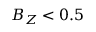Convert formula to latex. <formula><loc_0><loc_0><loc_500><loc_500>B _ { Z } < 0 . 5</formula> 